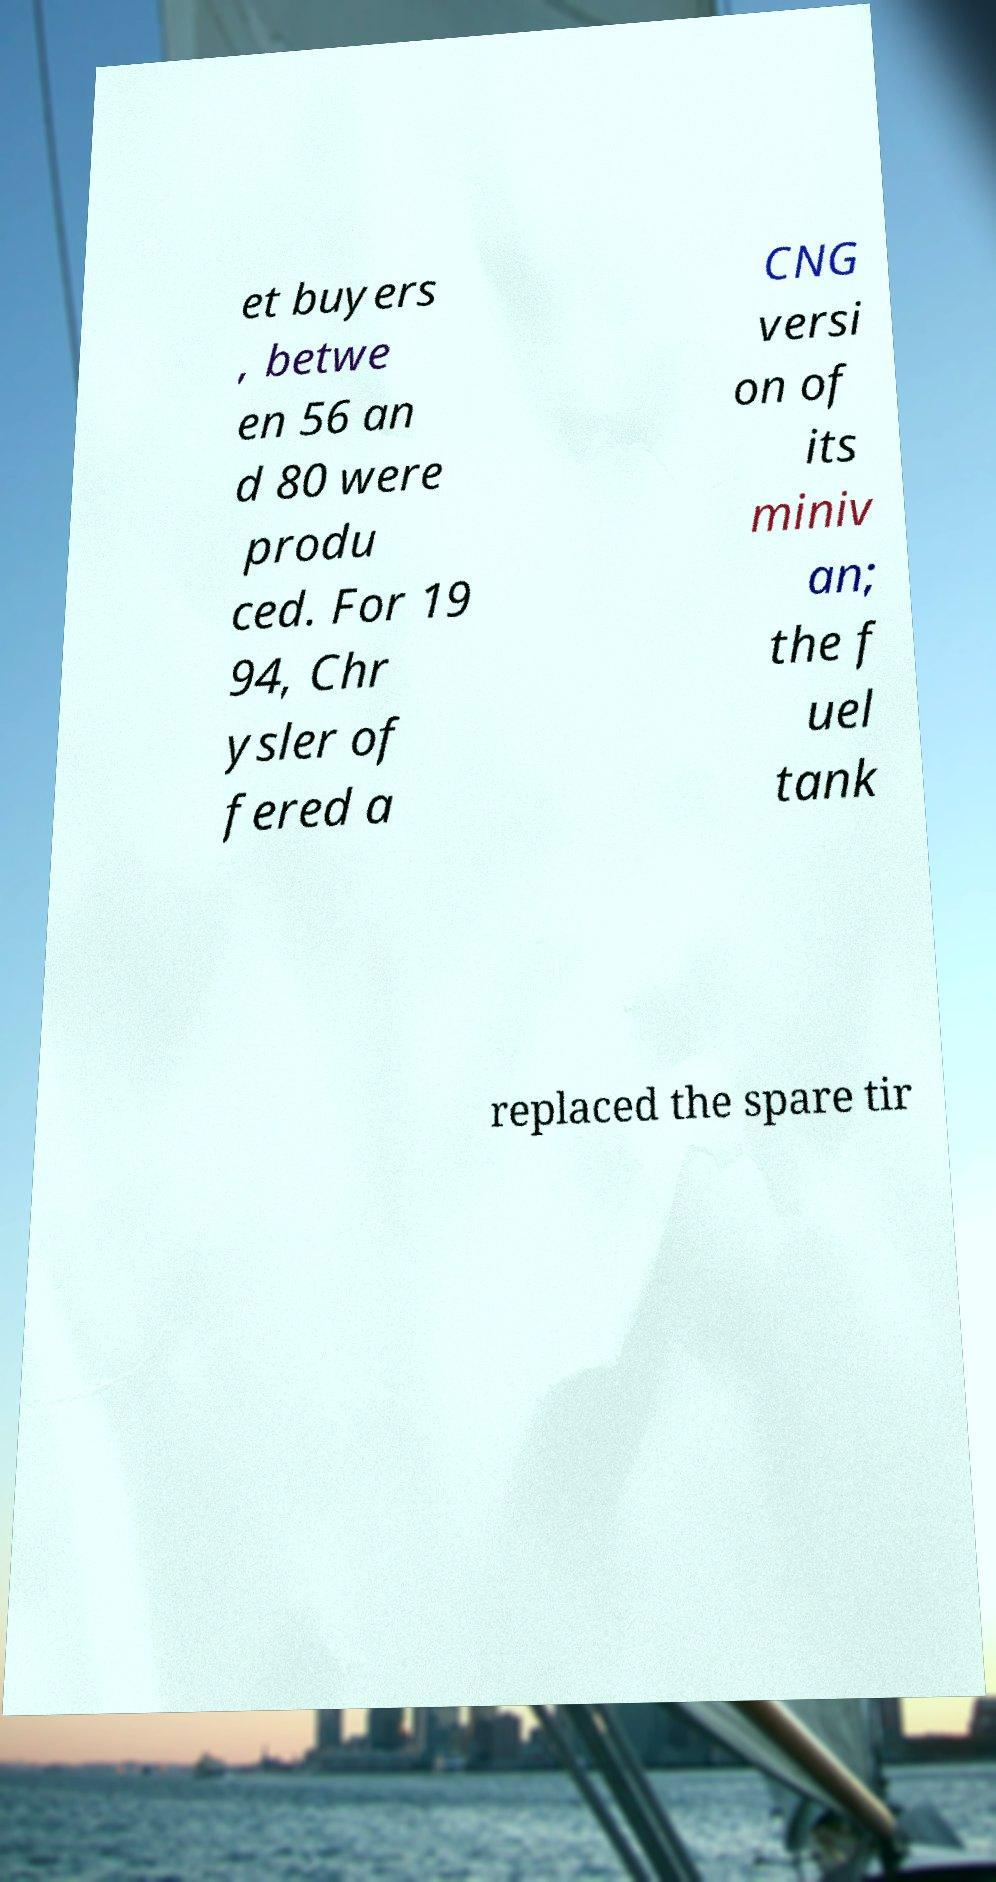Can you read and provide the text displayed in the image?This photo seems to have some interesting text. Can you extract and type it out for me? et buyers , betwe en 56 an d 80 were produ ced. For 19 94, Chr ysler of fered a CNG versi on of its miniv an; the f uel tank replaced the spare tir 